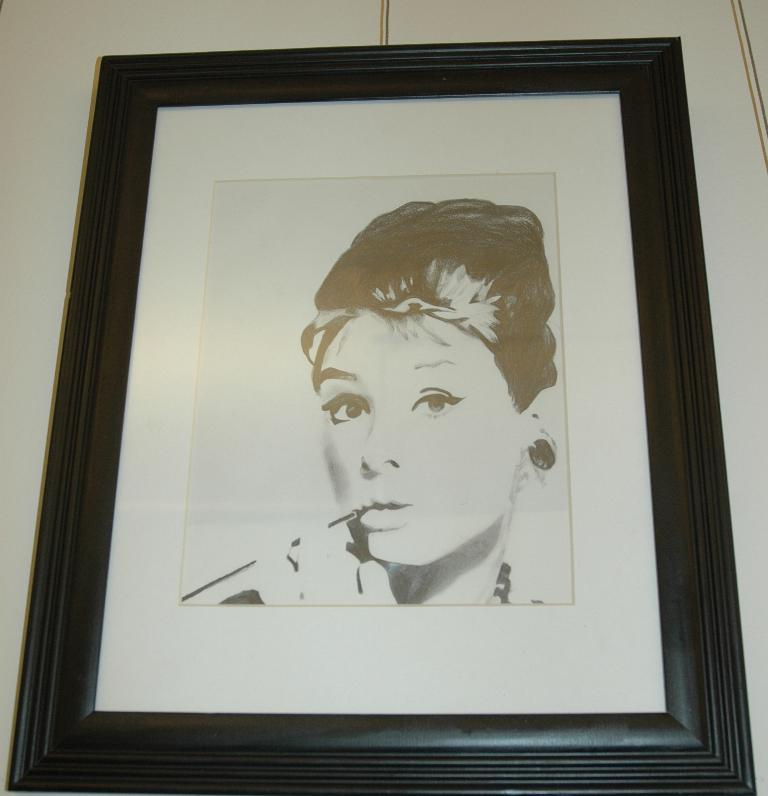What is the main subject of the image? There is a person's face in the image. How is the image displayed? The image is in a frame. Where is the frame located? The frame is attached to a wall. What type of mountain can be seen in the background of the image? There is no mountain visible in the image; it features a person's face in a frame attached to a wall. 